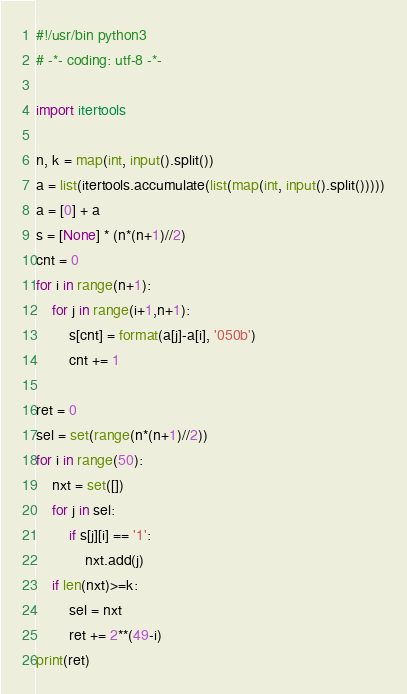<code> <loc_0><loc_0><loc_500><loc_500><_Python_>#!/usr/bin python3
# -*- coding: utf-8 -*-

import itertools

n, k = map(int, input().split())
a = list(itertools.accumulate(list(map(int, input().split()))))
a = [0] + a
s = [None] * (n*(n+1)//2)
cnt = 0
for i in range(n+1):
    for j in range(i+1,n+1):
        s[cnt] = format(a[j]-a[i], '050b')
        cnt += 1

ret = 0
sel = set(range(n*(n+1)//2))
for i in range(50):
    nxt = set([])
    for j in sel:
        if s[j][i] == '1':
            nxt.add(j)
    if len(nxt)>=k:
        sel = nxt
        ret += 2**(49-i)
print(ret)
</code> 